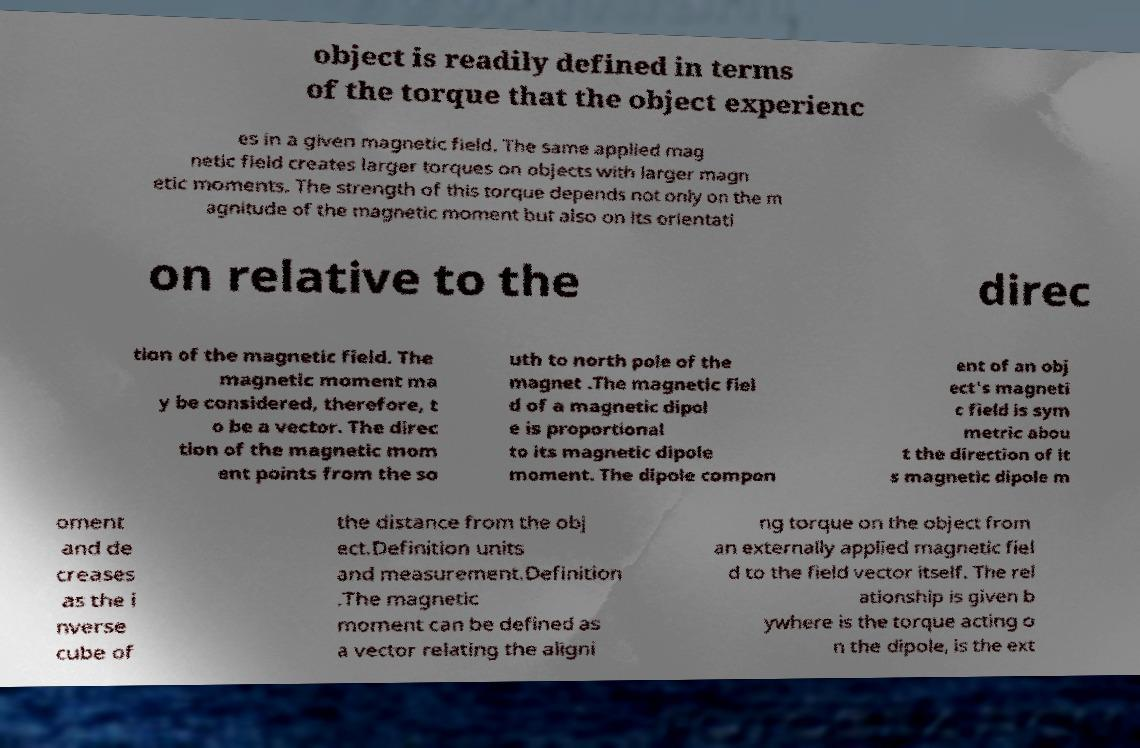Can you read and provide the text displayed in the image?This photo seems to have some interesting text. Can you extract and type it out for me? object is readily defined in terms of the torque that the object experienc es in a given magnetic field. The same applied mag netic field creates larger torques on objects with larger magn etic moments. The strength of this torque depends not only on the m agnitude of the magnetic moment but also on its orientati on relative to the direc tion of the magnetic field. The magnetic moment ma y be considered, therefore, t o be a vector. The direc tion of the magnetic mom ent points from the so uth to north pole of the magnet .The magnetic fiel d of a magnetic dipol e is proportional to its magnetic dipole moment. The dipole compon ent of an obj ect's magneti c field is sym metric abou t the direction of it s magnetic dipole m oment and de creases as the i nverse cube of the distance from the obj ect.Definition units and measurement.Definition .The magnetic moment can be defined as a vector relating the aligni ng torque on the object from an externally applied magnetic fiel d to the field vector itself. The rel ationship is given b ywhere is the torque acting o n the dipole, is the ext 